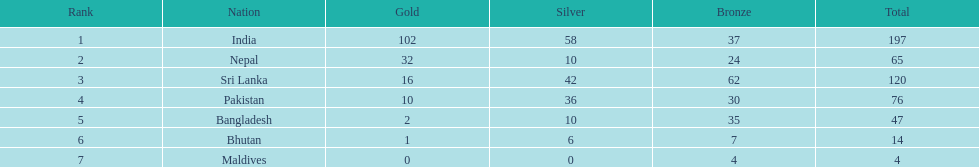In which country have no silver medals been won? Maldives. 